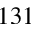<formula> <loc_0><loc_0><loc_500><loc_500>1 3 1</formula> 